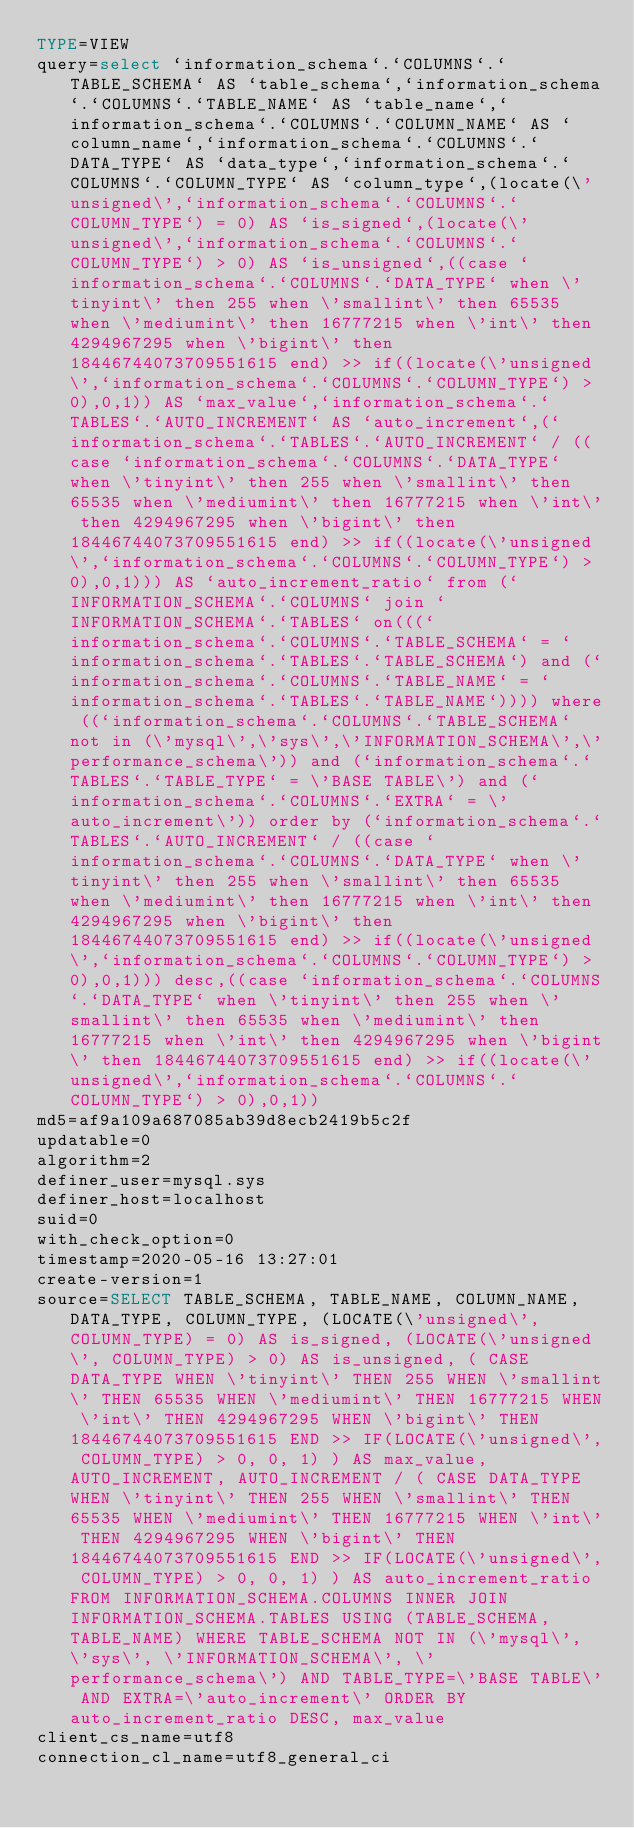Convert code to text. <code><loc_0><loc_0><loc_500><loc_500><_VisualBasic_>TYPE=VIEW
query=select `information_schema`.`COLUMNS`.`TABLE_SCHEMA` AS `table_schema`,`information_schema`.`COLUMNS`.`TABLE_NAME` AS `table_name`,`information_schema`.`COLUMNS`.`COLUMN_NAME` AS `column_name`,`information_schema`.`COLUMNS`.`DATA_TYPE` AS `data_type`,`information_schema`.`COLUMNS`.`COLUMN_TYPE` AS `column_type`,(locate(\'unsigned\',`information_schema`.`COLUMNS`.`COLUMN_TYPE`) = 0) AS `is_signed`,(locate(\'unsigned\',`information_schema`.`COLUMNS`.`COLUMN_TYPE`) > 0) AS `is_unsigned`,((case `information_schema`.`COLUMNS`.`DATA_TYPE` when \'tinyint\' then 255 when \'smallint\' then 65535 when \'mediumint\' then 16777215 when \'int\' then 4294967295 when \'bigint\' then 18446744073709551615 end) >> if((locate(\'unsigned\',`information_schema`.`COLUMNS`.`COLUMN_TYPE`) > 0),0,1)) AS `max_value`,`information_schema`.`TABLES`.`AUTO_INCREMENT` AS `auto_increment`,(`information_schema`.`TABLES`.`AUTO_INCREMENT` / ((case `information_schema`.`COLUMNS`.`DATA_TYPE` when \'tinyint\' then 255 when \'smallint\' then 65535 when \'mediumint\' then 16777215 when \'int\' then 4294967295 when \'bigint\' then 18446744073709551615 end) >> if((locate(\'unsigned\',`information_schema`.`COLUMNS`.`COLUMN_TYPE`) > 0),0,1))) AS `auto_increment_ratio` from (`INFORMATION_SCHEMA`.`COLUMNS` join `INFORMATION_SCHEMA`.`TABLES` on(((`information_schema`.`COLUMNS`.`TABLE_SCHEMA` = `information_schema`.`TABLES`.`TABLE_SCHEMA`) and (`information_schema`.`COLUMNS`.`TABLE_NAME` = `information_schema`.`TABLES`.`TABLE_NAME`)))) where ((`information_schema`.`COLUMNS`.`TABLE_SCHEMA` not in (\'mysql\',\'sys\',\'INFORMATION_SCHEMA\',\'performance_schema\')) and (`information_schema`.`TABLES`.`TABLE_TYPE` = \'BASE TABLE\') and (`information_schema`.`COLUMNS`.`EXTRA` = \'auto_increment\')) order by (`information_schema`.`TABLES`.`AUTO_INCREMENT` / ((case `information_schema`.`COLUMNS`.`DATA_TYPE` when \'tinyint\' then 255 when \'smallint\' then 65535 when \'mediumint\' then 16777215 when \'int\' then 4294967295 when \'bigint\' then 18446744073709551615 end) >> if((locate(\'unsigned\',`information_schema`.`COLUMNS`.`COLUMN_TYPE`) > 0),0,1))) desc,((case `information_schema`.`COLUMNS`.`DATA_TYPE` when \'tinyint\' then 255 when \'smallint\' then 65535 when \'mediumint\' then 16777215 when \'int\' then 4294967295 when \'bigint\' then 18446744073709551615 end) >> if((locate(\'unsigned\',`information_schema`.`COLUMNS`.`COLUMN_TYPE`) > 0),0,1))
md5=af9a109a687085ab39d8ecb2419b5c2f
updatable=0
algorithm=2
definer_user=mysql.sys
definer_host=localhost
suid=0
with_check_option=0
timestamp=2020-05-16 13:27:01
create-version=1
source=SELECT TABLE_SCHEMA, TABLE_NAME, COLUMN_NAME, DATA_TYPE, COLUMN_TYPE, (LOCATE(\'unsigned\', COLUMN_TYPE) = 0) AS is_signed, (LOCATE(\'unsigned\', COLUMN_TYPE) > 0) AS is_unsigned, ( CASE DATA_TYPE WHEN \'tinyint\' THEN 255 WHEN \'smallint\' THEN 65535 WHEN \'mediumint\' THEN 16777215 WHEN \'int\' THEN 4294967295 WHEN \'bigint\' THEN 18446744073709551615 END >> IF(LOCATE(\'unsigned\', COLUMN_TYPE) > 0, 0, 1) ) AS max_value, AUTO_INCREMENT, AUTO_INCREMENT / ( CASE DATA_TYPE WHEN \'tinyint\' THEN 255 WHEN \'smallint\' THEN 65535 WHEN \'mediumint\' THEN 16777215 WHEN \'int\' THEN 4294967295 WHEN \'bigint\' THEN 18446744073709551615 END >> IF(LOCATE(\'unsigned\', COLUMN_TYPE) > 0, 0, 1) ) AS auto_increment_ratio FROM INFORMATION_SCHEMA.COLUMNS INNER JOIN INFORMATION_SCHEMA.TABLES USING (TABLE_SCHEMA, TABLE_NAME) WHERE TABLE_SCHEMA NOT IN (\'mysql\', \'sys\', \'INFORMATION_SCHEMA\', \'performance_schema\') AND TABLE_TYPE=\'BASE TABLE\' AND EXTRA=\'auto_increment\' ORDER BY auto_increment_ratio DESC, max_value
client_cs_name=utf8
connection_cl_name=utf8_general_ci</code> 